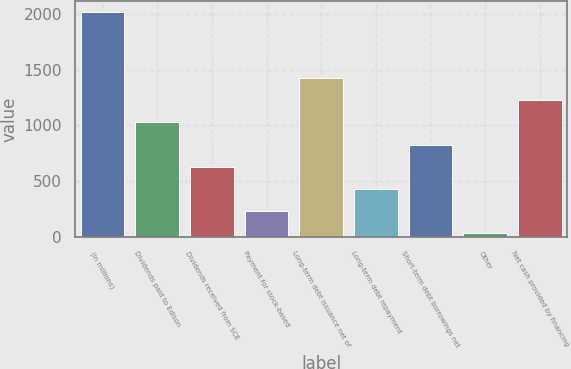Convert chart to OTSL. <chart><loc_0><loc_0><loc_500><loc_500><bar_chart><fcel>(in millions)<fcel>Dividends paid to Edison<fcel>Dividends received from SCE<fcel>Payment for stock-based<fcel>Long-term debt issuance net of<fcel>Long-term debt repayment<fcel>Short-term debt borrowings net<fcel>Other<fcel>Net cash provided by financing<nl><fcel>2017<fcel>1027.5<fcel>631.7<fcel>235.9<fcel>1423.3<fcel>433.8<fcel>829.6<fcel>38<fcel>1225.4<nl></chart> 